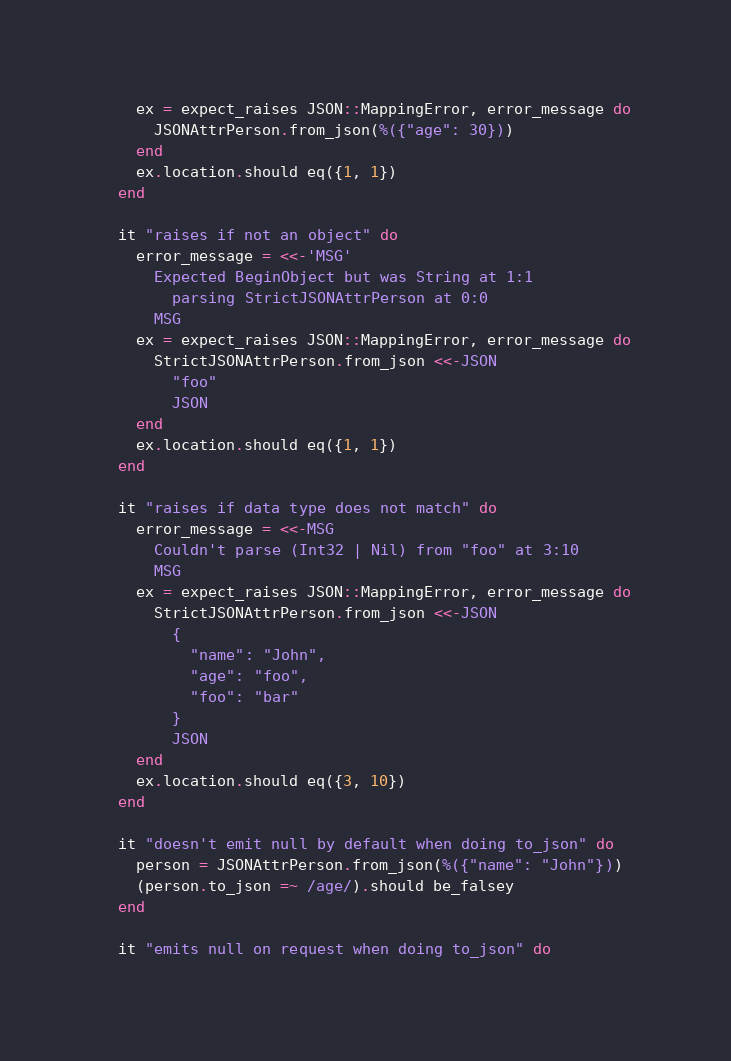<code> <loc_0><loc_0><loc_500><loc_500><_Crystal_>    ex = expect_raises JSON::MappingError, error_message do
      JSONAttrPerson.from_json(%({"age": 30}))
    end
    ex.location.should eq({1, 1})
  end

  it "raises if not an object" do
    error_message = <<-'MSG'
      Expected BeginObject but was String at 1:1
        parsing StrictJSONAttrPerson at 0:0
      MSG
    ex = expect_raises JSON::MappingError, error_message do
      StrictJSONAttrPerson.from_json <<-JSON
        "foo"
        JSON
    end
    ex.location.should eq({1, 1})
  end

  it "raises if data type does not match" do
    error_message = <<-MSG
      Couldn't parse (Int32 | Nil) from "foo" at 3:10
      MSG
    ex = expect_raises JSON::MappingError, error_message do
      StrictJSONAttrPerson.from_json <<-JSON
        {
          "name": "John",
          "age": "foo",
          "foo": "bar"
        }
        JSON
    end
    ex.location.should eq({3, 10})
  end

  it "doesn't emit null by default when doing to_json" do
    person = JSONAttrPerson.from_json(%({"name": "John"}))
    (person.to_json =~ /age/).should be_falsey
  end

  it "emits null on request when doing to_json" do</code> 